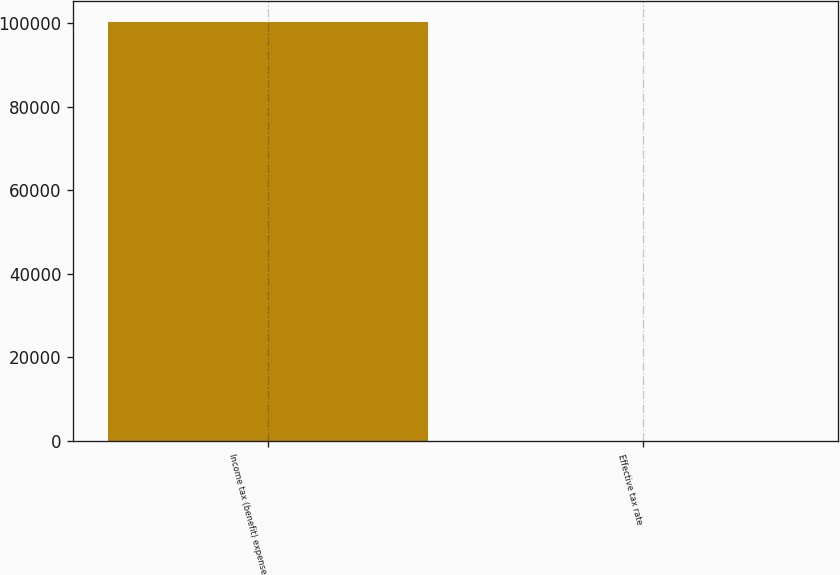Convert chart to OTSL. <chart><loc_0><loc_0><loc_500><loc_500><bar_chart><fcel>Income tax (benefit) expense<fcel>Effective tax rate<nl><fcel>100210<fcel>24<nl></chart> 